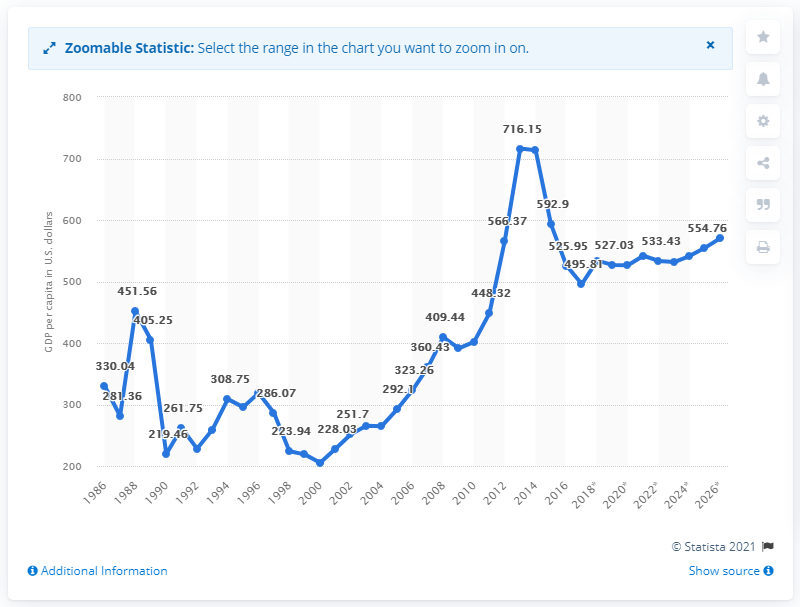Give some essential details in this illustration. In 2017, the Gross Domestic Product (GDP) per capita in Sierra Leone was 495.81. 